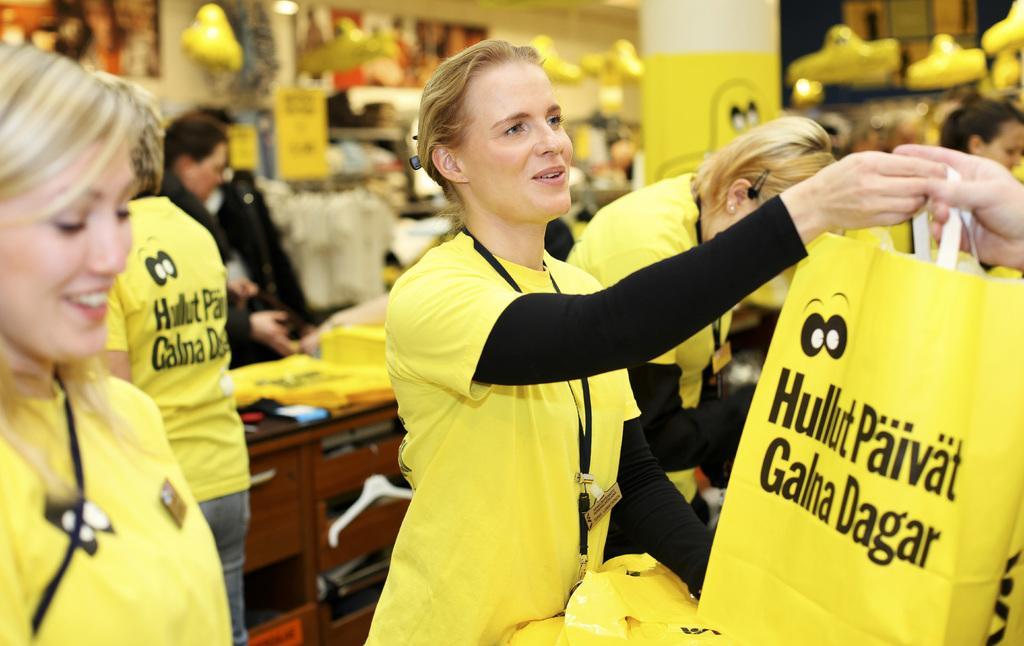Describe this image in one or two sentences. The girl in the middle of the picture wearing yellow T-shirt and ID card is holding a yellow color plastic bag in her hand. She is trying to talk something. Beside her, we see people wearing yellow T-shirts are standing. Behind them, we see a table on which yellow bags are placed. There are many toys in the background. This picture might be clicked in the shop. 